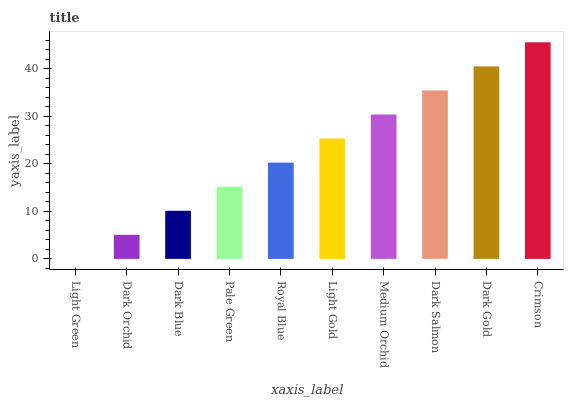Is Light Green the minimum?
Answer yes or no. Yes. Is Crimson the maximum?
Answer yes or no. Yes. Is Dark Orchid the minimum?
Answer yes or no. No. Is Dark Orchid the maximum?
Answer yes or no. No. Is Dark Orchid greater than Light Green?
Answer yes or no. Yes. Is Light Green less than Dark Orchid?
Answer yes or no. Yes. Is Light Green greater than Dark Orchid?
Answer yes or no. No. Is Dark Orchid less than Light Green?
Answer yes or no. No. Is Light Gold the high median?
Answer yes or no. Yes. Is Royal Blue the low median?
Answer yes or no. Yes. Is Dark Salmon the high median?
Answer yes or no. No. Is Dark Orchid the low median?
Answer yes or no. No. 